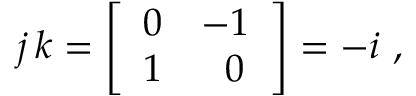<formula> <loc_0><loc_0><loc_500><loc_500>j \, k = { \left [ \begin{array} { l l } { 0 } & { - 1 } \\ { 1 } & { \, 0 } \end{array} \right ] } = - i ,</formula> 